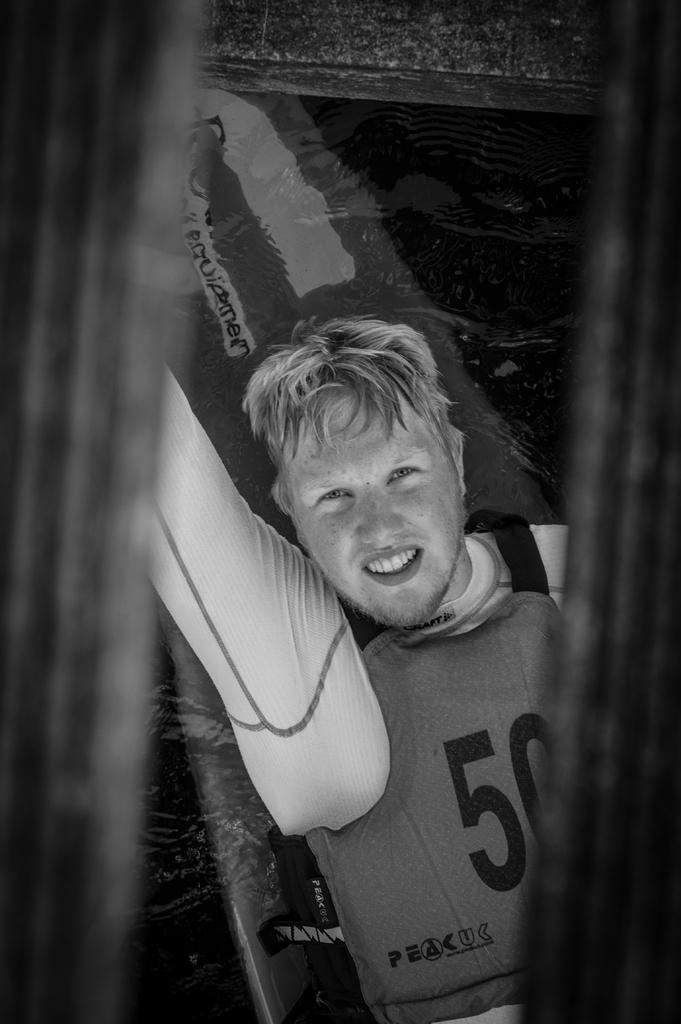Please provide a concise description of this image. This is a black and white image. In this image, we can see a person. Behind the person, we can see the water and surfing board. On the right side and left side of the image, there is a blur view. 